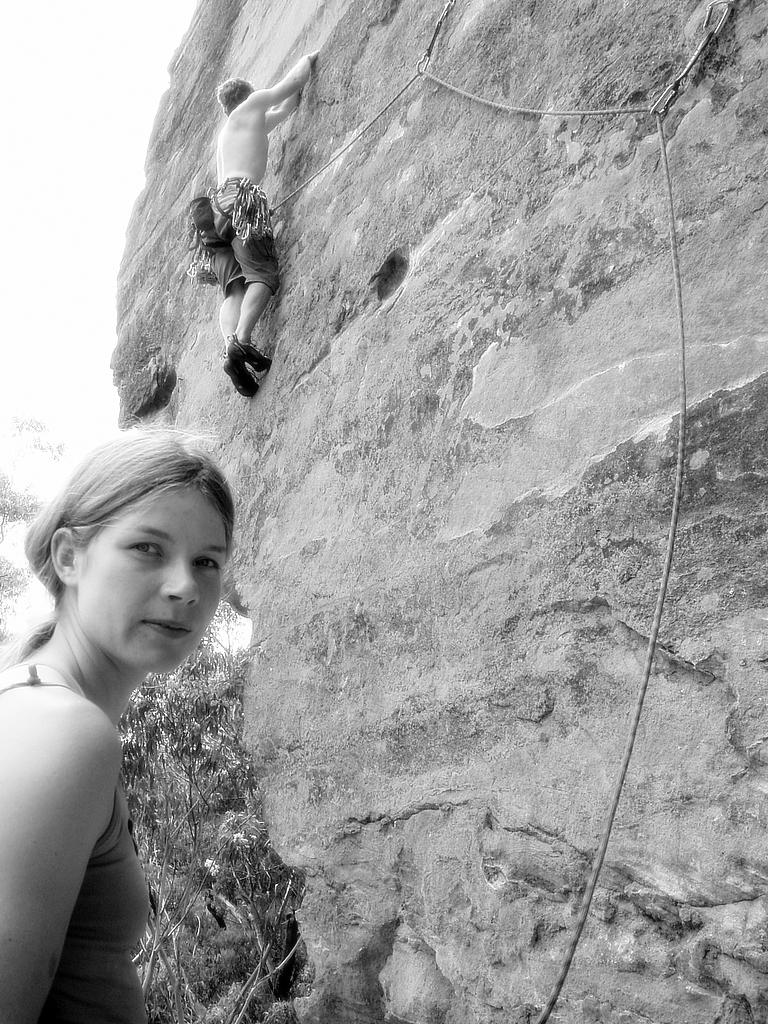How many people are in the image? There are two persons in the image. What is one of the persons doing in the image? One person is climbing a wall. What can be seen in the background of the image? There are trees in the background of the image. What is located on the right side of the image? There is a rock on the right side of the image. What is visible at the top of the image? The sky is visible at the top of the image. What type of hospital can be seen in the image? There is no hospital present in the image. How does the person care for the rock while climbing the wall? The person is not caring for the rock while climbing the wall; they are simply climbing the wall. 